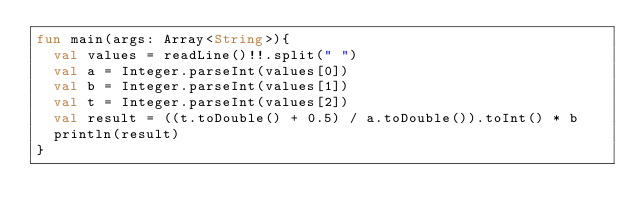<code> <loc_0><loc_0><loc_500><loc_500><_Kotlin_>fun main(args: Array<String>){
  val values = readLine()!!.split(" ")
  val a = Integer.parseInt(values[0])
  val b = Integer.parseInt(values[1])
  val t = Integer.parseInt(values[2])
  val result = ((t.toDouble() + 0.5) / a.toDouble()).toInt() * b
  println(result)
}</code> 